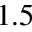Convert formula to latex. <formula><loc_0><loc_0><loc_500><loc_500>1 . 5</formula> 